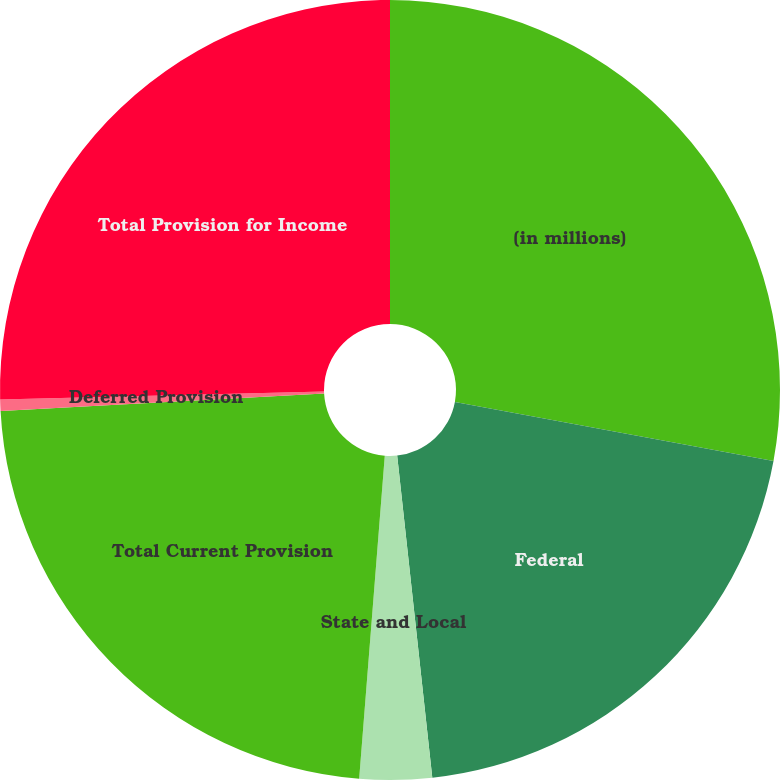<chart> <loc_0><loc_0><loc_500><loc_500><pie_chart><fcel>(in millions)<fcel>Federal<fcel>State and Local<fcel>Total Current Provision<fcel>Deferred Provision<fcel>Total Provision for Income<nl><fcel>27.91%<fcel>20.36%<fcel>2.99%<fcel>22.88%<fcel>0.47%<fcel>25.39%<nl></chart> 